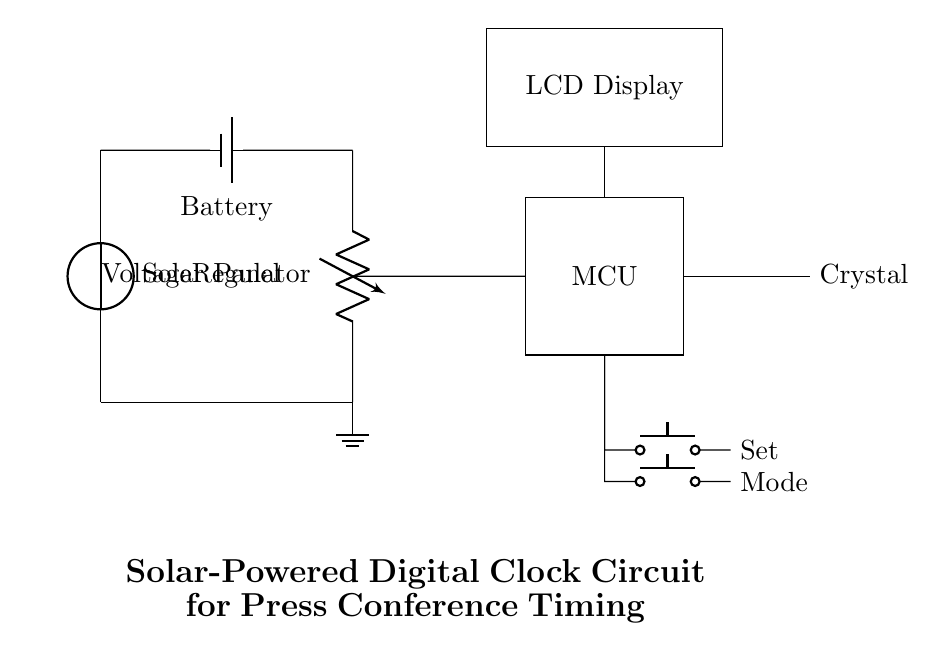What component converts solar energy into electrical energy? The solar panel is responsible for converting solar energy into electrical energy, as shown at the top of the circuit diagram.
Answer: Solar Panel What does the battery do in this circuit? The battery stores electrical energy produced by the solar panel and provides a constant supply of voltage to the circuit, ensuring it operates reliably.
Answer: Battery What is the function of the voltage regulator? The voltage regulator ensures that a stable voltage level is delivered from the battery to the microcontroller and other components, preventing damage from voltage fluctuations.
Answer: Stabilizes Voltage Which component displays the time in this circuit? The LCD display shows the time and other information as output, receiving signals from the microcontroller.
Answer: LCD Display How many buttons are included for user interface? There are two buttons, one for setting the time and one for changing modes, allowing user interaction with the digital clock functionality.
Answer: Two Buttons Explain the relationship between the microcontroller and the crystal oscillator. The microcontroller relies on the crystal oscillator to provide a precise clock signal, which is essential for accurate timekeeping in a digital clock.
Answer: Clock Signal What is the primary power source for this digital clock circuit? The primary power source is the solar panel, which harnesses solar energy to power the entire circuit.
Answer: Solar Panel 